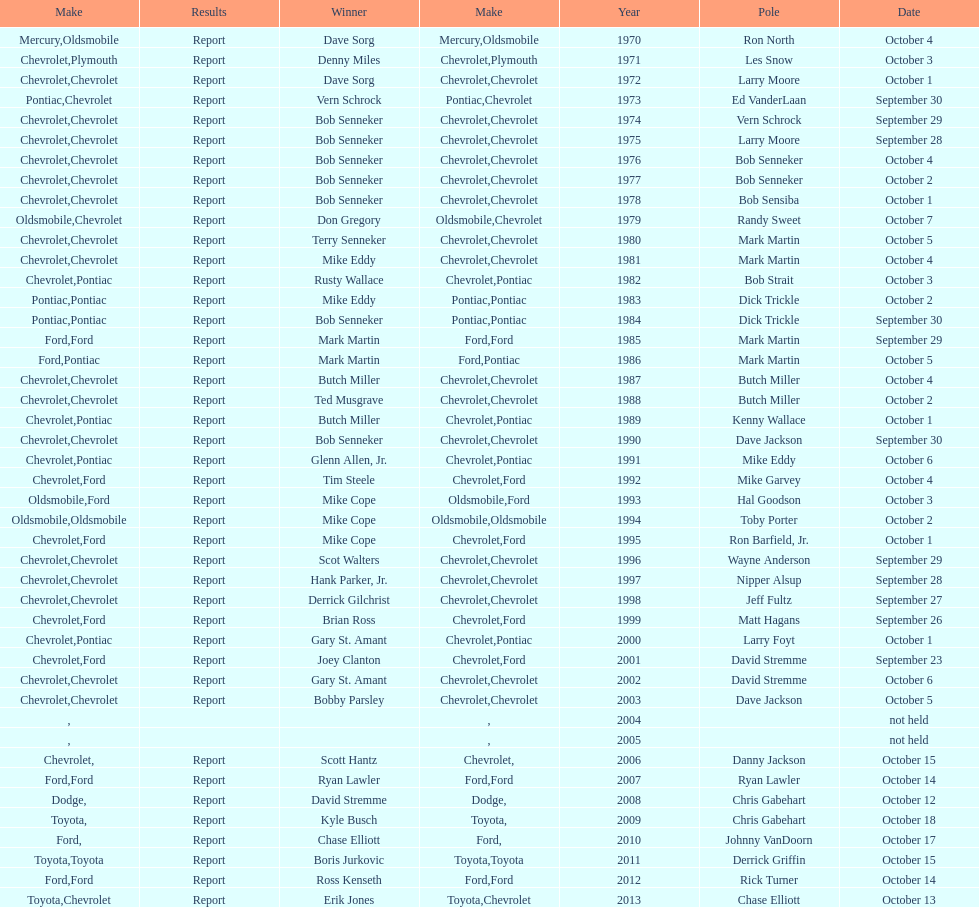Which month held the most winchester 400 races? October. 